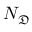Convert formula to latex. <formula><loc_0><loc_0><loc_500><loc_500>{ N _ { \mathfrak { D } } }</formula> 